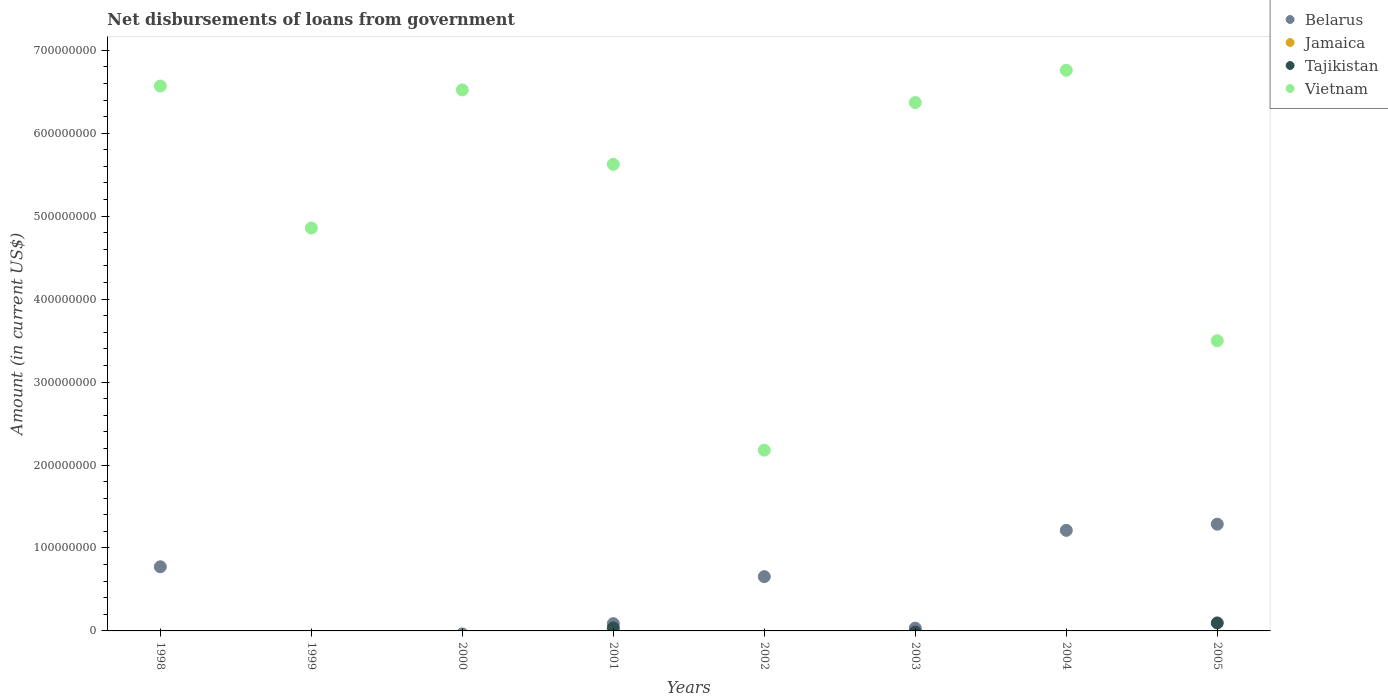What is the amount of loan disbursed from government in Jamaica in 1998?
Offer a very short reply. 0. Across all years, what is the maximum amount of loan disbursed from government in Vietnam?
Offer a terse response. 6.76e+08. In which year was the amount of loan disbursed from government in Belarus maximum?
Offer a very short reply. 2005. What is the total amount of loan disbursed from government in Vietnam in the graph?
Keep it short and to the point. 4.24e+09. What is the difference between the amount of loan disbursed from government in Belarus in 2002 and that in 2003?
Your answer should be very brief. 6.21e+07. What is the average amount of loan disbursed from government in Tajikistan per year?
Make the answer very short. 1.65e+06. In the year 2005, what is the difference between the amount of loan disbursed from government in Tajikistan and amount of loan disbursed from government in Belarus?
Make the answer very short. -1.19e+08. What is the ratio of the amount of loan disbursed from government in Belarus in 1998 to that in 2003?
Provide a short and direct response. 22.94. Is the amount of loan disbursed from government in Vietnam in 2000 less than that in 2005?
Give a very brief answer. No. What is the difference between the highest and the second highest amount of loan disbursed from government in Vietnam?
Give a very brief answer. 1.90e+07. What is the difference between the highest and the lowest amount of loan disbursed from government in Vietnam?
Your answer should be compact. 4.58e+08. In how many years, is the amount of loan disbursed from government in Jamaica greater than the average amount of loan disbursed from government in Jamaica taken over all years?
Provide a succinct answer. 0. Is the sum of the amount of loan disbursed from government in Vietnam in 2001 and 2002 greater than the maximum amount of loan disbursed from government in Belarus across all years?
Offer a terse response. Yes. Is it the case that in every year, the sum of the amount of loan disbursed from government in Tajikistan and amount of loan disbursed from government in Belarus  is greater than the sum of amount of loan disbursed from government in Vietnam and amount of loan disbursed from government in Jamaica?
Give a very brief answer. No. Is it the case that in every year, the sum of the amount of loan disbursed from government in Vietnam and amount of loan disbursed from government in Tajikistan  is greater than the amount of loan disbursed from government in Jamaica?
Your answer should be very brief. Yes. What is the difference between two consecutive major ticks on the Y-axis?
Give a very brief answer. 1.00e+08. Are the values on the major ticks of Y-axis written in scientific E-notation?
Provide a short and direct response. No. Does the graph contain any zero values?
Your response must be concise. Yes. What is the title of the graph?
Ensure brevity in your answer.  Net disbursements of loans from government. Does "Latin America(developing only)" appear as one of the legend labels in the graph?
Ensure brevity in your answer.  No. What is the label or title of the X-axis?
Provide a short and direct response. Years. What is the Amount (in current US$) in Belarus in 1998?
Offer a terse response. 7.73e+07. What is the Amount (in current US$) in Vietnam in 1998?
Give a very brief answer. 6.57e+08. What is the Amount (in current US$) in Belarus in 1999?
Give a very brief answer. 0. What is the Amount (in current US$) of Jamaica in 1999?
Make the answer very short. 0. What is the Amount (in current US$) of Tajikistan in 1999?
Provide a short and direct response. 0. What is the Amount (in current US$) of Vietnam in 1999?
Your response must be concise. 4.86e+08. What is the Amount (in current US$) of Jamaica in 2000?
Provide a succinct answer. 0. What is the Amount (in current US$) of Tajikistan in 2000?
Provide a succinct answer. 0. What is the Amount (in current US$) in Vietnam in 2000?
Give a very brief answer. 6.52e+08. What is the Amount (in current US$) of Belarus in 2001?
Your response must be concise. 8.79e+06. What is the Amount (in current US$) of Jamaica in 2001?
Provide a short and direct response. 0. What is the Amount (in current US$) in Tajikistan in 2001?
Provide a short and direct response. 3.58e+06. What is the Amount (in current US$) in Vietnam in 2001?
Keep it short and to the point. 5.62e+08. What is the Amount (in current US$) in Belarus in 2002?
Ensure brevity in your answer.  6.54e+07. What is the Amount (in current US$) of Jamaica in 2002?
Keep it short and to the point. 0. What is the Amount (in current US$) in Tajikistan in 2002?
Ensure brevity in your answer.  0. What is the Amount (in current US$) in Vietnam in 2002?
Offer a very short reply. 2.18e+08. What is the Amount (in current US$) of Belarus in 2003?
Your answer should be compact. 3.37e+06. What is the Amount (in current US$) of Jamaica in 2003?
Provide a succinct answer. 0. What is the Amount (in current US$) in Vietnam in 2003?
Your answer should be compact. 6.37e+08. What is the Amount (in current US$) of Belarus in 2004?
Provide a succinct answer. 1.21e+08. What is the Amount (in current US$) of Jamaica in 2004?
Ensure brevity in your answer.  0. What is the Amount (in current US$) of Vietnam in 2004?
Offer a terse response. 6.76e+08. What is the Amount (in current US$) in Belarus in 2005?
Give a very brief answer. 1.29e+08. What is the Amount (in current US$) of Tajikistan in 2005?
Your answer should be very brief. 9.63e+06. What is the Amount (in current US$) of Vietnam in 2005?
Give a very brief answer. 3.50e+08. Across all years, what is the maximum Amount (in current US$) in Belarus?
Keep it short and to the point. 1.29e+08. Across all years, what is the maximum Amount (in current US$) in Tajikistan?
Your answer should be compact. 9.63e+06. Across all years, what is the maximum Amount (in current US$) in Vietnam?
Your response must be concise. 6.76e+08. Across all years, what is the minimum Amount (in current US$) in Vietnam?
Your response must be concise. 2.18e+08. What is the total Amount (in current US$) of Belarus in the graph?
Your response must be concise. 4.05e+08. What is the total Amount (in current US$) of Tajikistan in the graph?
Offer a terse response. 1.32e+07. What is the total Amount (in current US$) in Vietnam in the graph?
Offer a very short reply. 4.24e+09. What is the difference between the Amount (in current US$) of Vietnam in 1998 and that in 1999?
Your answer should be compact. 1.71e+08. What is the difference between the Amount (in current US$) of Vietnam in 1998 and that in 2000?
Your response must be concise. 4.68e+06. What is the difference between the Amount (in current US$) of Belarus in 1998 and that in 2001?
Provide a succinct answer. 6.85e+07. What is the difference between the Amount (in current US$) in Vietnam in 1998 and that in 2001?
Your response must be concise. 9.44e+07. What is the difference between the Amount (in current US$) in Belarus in 1998 and that in 2002?
Your answer should be compact. 1.19e+07. What is the difference between the Amount (in current US$) of Vietnam in 1998 and that in 2002?
Offer a very short reply. 4.39e+08. What is the difference between the Amount (in current US$) of Belarus in 1998 and that in 2003?
Keep it short and to the point. 7.40e+07. What is the difference between the Amount (in current US$) of Vietnam in 1998 and that in 2003?
Your answer should be very brief. 2.00e+07. What is the difference between the Amount (in current US$) in Belarus in 1998 and that in 2004?
Your answer should be very brief. -4.39e+07. What is the difference between the Amount (in current US$) in Vietnam in 1998 and that in 2004?
Provide a short and direct response. -1.90e+07. What is the difference between the Amount (in current US$) of Belarus in 1998 and that in 2005?
Offer a terse response. -5.14e+07. What is the difference between the Amount (in current US$) in Vietnam in 1998 and that in 2005?
Your answer should be very brief. 3.07e+08. What is the difference between the Amount (in current US$) in Vietnam in 1999 and that in 2000?
Ensure brevity in your answer.  -1.66e+08. What is the difference between the Amount (in current US$) of Vietnam in 1999 and that in 2001?
Make the answer very short. -7.67e+07. What is the difference between the Amount (in current US$) in Vietnam in 1999 and that in 2002?
Offer a terse response. 2.68e+08. What is the difference between the Amount (in current US$) of Vietnam in 1999 and that in 2003?
Offer a terse response. -1.51e+08. What is the difference between the Amount (in current US$) of Vietnam in 1999 and that in 2004?
Ensure brevity in your answer.  -1.90e+08. What is the difference between the Amount (in current US$) of Vietnam in 1999 and that in 2005?
Offer a terse response. 1.36e+08. What is the difference between the Amount (in current US$) of Vietnam in 2000 and that in 2001?
Ensure brevity in your answer.  8.97e+07. What is the difference between the Amount (in current US$) in Vietnam in 2000 and that in 2002?
Provide a succinct answer. 4.34e+08. What is the difference between the Amount (in current US$) of Vietnam in 2000 and that in 2003?
Your answer should be very brief. 1.53e+07. What is the difference between the Amount (in current US$) of Vietnam in 2000 and that in 2004?
Ensure brevity in your answer.  -2.37e+07. What is the difference between the Amount (in current US$) of Vietnam in 2000 and that in 2005?
Ensure brevity in your answer.  3.02e+08. What is the difference between the Amount (in current US$) of Belarus in 2001 and that in 2002?
Your answer should be very brief. -5.66e+07. What is the difference between the Amount (in current US$) in Vietnam in 2001 and that in 2002?
Give a very brief answer. 3.45e+08. What is the difference between the Amount (in current US$) in Belarus in 2001 and that in 2003?
Give a very brief answer. 5.42e+06. What is the difference between the Amount (in current US$) in Vietnam in 2001 and that in 2003?
Make the answer very short. -7.45e+07. What is the difference between the Amount (in current US$) in Belarus in 2001 and that in 2004?
Offer a terse response. -1.12e+08. What is the difference between the Amount (in current US$) of Vietnam in 2001 and that in 2004?
Your response must be concise. -1.13e+08. What is the difference between the Amount (in current US$) of Belarus in 2001 and that in 2005?
Offer a very short reply. -1.20e+08. What is the difference between the Amount (in current US$) of Tajikistan in 2001 and that in 2005?
Keep it short and to the point. -6.04e+06. What is the difference between the Amount (in current US$) of Vietnam in 2001 and that in 2005?
Keep it short and to the point. 2.13e+08. What is the difference between the Amount (in current US$) in Belarus in 2002 and that in 2003?
Your answer should be compact. 6.21e+07. What is the difference between the Amount (in current US$) in Vietnam in 2002 and that in 2003?
Give a very brief answer. -4.19e+08. What is the difference between the Amount (in current US$) in Belarus in 2002 and that in 2004?
Keep it short and to the point. -5.58e+07. What is the difference between the Amount (in current US$) of Vietnam in 2002 and that in 2004?
Your response must be concise. -4.58e+08. What is the difference between the Amount (in current US$) of Belarus in 2002 and that in 2005?
Offer a terse response. -6.33e+07. What is the difference between the Amount (in current US$) in Vietnam in 2002 and that in 2005?
Your response must be concise. -1.32e+08. What is the difference between the Amount (in current US$) of Belarus in 2003 and that in 2004?
Make the answer very short. -1.18e+08. What is the difference between the Amount (in current US$) of Vietnam in 2003 and that in 2004?
Ensure brevity in your answer.  -3.90e+07. What is the difference between the Amount (in current US$) in Belarus in 2003 and that in 2005?
Provide a short and direct response. -1.25e+08. What is the difference between the Amount (in current US$) in Vietnam in 2003 and that in 2005?
Your answer should be very brief. 2.87e+08. What is the difference between the Amount (in current US$) in Belarus in 2004 and that in 2005?
Your answer should be compact. -7.44e+06. What is the difference between the Amount (in current US$) in Vietnam in 2004 and that in 2005?
Keep it short and to the point. 3.26e+08. What is the difference between the Amount (in current US$) of Belarus in 1998 and the Amount (in current US$) of Vietnam in 1999?
Offer a very short reply. -4.08e+08. What is the difference between the Amount (in current US$) in Belarus in 1998 and the Amount (in current US$) in Vietnam in 2000?
Your answer should be compact. -5.75e+08. What is the difference between the Amount (in current US$) of Belarus in 1998 and the Amount (in current US$) of Tajikistan in 2001?
Ensure brevity in your answer.  7.37e+07. What is the difference between the Amount (in current US$) in Belarus in 1998 and the Amount (in current US$) in Vietnam in 2001?
Your response must be concise. -4.85e+08. What is the difference between the Amount (in current US$) of Belarus in 1998 and the Amount (in current US$) of Vietnam in 2002?
Ensure brevity in your answer.  -1.41e+08. What is the difference between the Amount (in current US$) in Belarus in 1998 and the Amount (in current US$) in Vietnam in 2003?
Offer a terse response. -5.60e+08. What is the difference between the Amount (in current US$) of Belarus in 1998 and the Amount (in current US$) of Vietnam in 2004?
Offer a very short reply. -5.99e+08. What is the difference between the Amount (in current US$) of Belarus in 1998 and the Amount (in current US$) of Tajikistan in 2005?
Ensure brevity in your answer.  6.77e+07. What is the difference between the Amount (in current US$) of Belarus in 1998 and the Amount (in current US$) of Vietnam in 2005?
Your response must be concise. -2.72e+08. What is the difference between the Amount (in current US$) of Belarus in 2001 and the Amount (in current US$) of Vietnam in 2002?
Ensure brevity in your answer.  -2.09e+08. What is the difference between the Amount (in current US$) of Tajikistan in 2001 and the Amount (in current US$) of Vietnam in 2002?
Offer a terse response. -2.14e+08. What is the difference between the Amount (in current US$) in Belarus in 2001 and the Amount (in current US$) in Vietnam in 2003?
Offer a terse response. -6.28e+08. What is the difference between the Amount (in current US$) of Tajikistan in 2001 and the Amount (in current US$) of Vietnam in 2003?
Offer a terse response. -6.33e+08. What is the difference between the Amount (in current US$) of Belarus in 2001 and the Amount (in current US$) of Vietnam in 2004?
Ensure brevity in your answer.  -6.67e+08. What is the difference between the Amount (in current US$) of Tajikistan in 2001 and the Amount (in current US$) of Vietnam in 2004?
Your answer should be very brief. -6.72e+08. What is the difference between the Amount (in current US$) of Belarus in 2001 and the Amount (in current US$) of Tajikistan in 2005?
Ensure brevity in your answer.  -8.33e+05. What is the difference between the Amount (in current US$) of Belarus in 2001 and the Amount (in current US$) of Vietnam in 2005?
Ensure brevity in your answer.  -3.41e+08. What is the difference between the Amount (in current US$) of Tajikistan in 2001 and the Amount (in current US$) of Vietnam in 2005?
Offer a very short reply. -3.46e+08. What is the difference between the Amount (in current US$) in Belarus in 2002 and the Amount (in current US$) in Vietnam in 2003?
Make the answer very short. -5.72e+08. What is the difference between the Amount (in current US$) of Belarus in 2002 and the Amount (in current US$) of Vietnam in 2004?
Make the answer very short. -6.10e+08. What is the difference between the Amount (in current US$) of Belarus in 2002 and the Amount (in current US$) of Tajikistan in 2005?
Provide a short and direct response. 5.58e+07. What is the difference between the Amount (in current US$) in Belarus in 2002 and the Amount (in current US$) in Vietnam in 2005?
Ensure brevity in your answer.  -2.84e+08. What is the difference between the Amount (in current US$) of Belarus in 2003 and the Amount (in current US$) of Vietnam in 2004?
Ensure brevity in your answer.  -6.73e+08. What is the difference between the Amount (in current US$) of Belarus in 2003 and the Amount (in current US$) of Tajikistan in 2005?
Give a very brief answer. -6.26e+06. What is the difference between the Amount (in current US$) of Belarus in 2003 and the Amount (in current US$) of Vietnam in 2005?
Offer a very short reply. -3.46e+08. What is the difference between the Amount (in current US$) in Belarus in 2004 and the Amount (in current US$) in Tajikistan in 2005?
Offer a terse response. 1.12e+08. What is the difference between the Amount (in current US$) in Belarus in 2004 and the Amount (in current US$) in Vietnam in 2005?
Provide a short and direct response. -2.29e+08. What is the average Amount (in current US$) of Belarus per year?
Keep it short and to the point. 5.06e+07. What is the average Amount (in current US$) of Jamaica per year?
Your answer should be very brief. 0. What is the average Amount (in current US$) of Tajikistan per year?
Offer a terse response. 1.65e+06. What is the average Amount (in current US$) of Vietnam per year?
Provide a succinct answer. 5.30e+08. In the year 1998, what is the difference between the Amount (in current US$) of Belarus and Amount (in current US$) of Vietnam?
Ensure brevity in your answer.  -5.80e+08. In the year 2001, what is the difference between the Amount (in current US$) of Belarus and Amount (in current US$) of Tajikistan?
Provide a succinct answer. 5.21e+06. In the year 2001, what is the difference between the Amount (in current US$) of Belarus and Amount (in current US$) of Vietnam?
Ensure brevity in your answer.  -5.54e+08. In the year 2001, what is the difference between the Amount (in current US$) in Tajikistan and Amount (in current US$) in Vietnam?
Ensure brevity in your answer.  -5.59e+08. In the year 2002, what is the difference between the Amount (in current US$) of Belarus and Amount (in current US$) of Vietnam?
Ensure brevity in your answer.  -1.52e+08. In the year 2003, what is the difference between the Amount (in current US$) of Belarus and Amount (in current US$) of Vietnam?
Provide a succinct answer. -6.34e+08. In the year 2004, what is the difference between the Amount (in current US$) of Belarus and Amount (in current US$) of Vietnam?
Make the answer very short. -5.55e+08. In the year 2005, what is the difference between the Amount (in current US$) in Belarus and Amount (in current US$) in Tajikistan?
Make the answer very short. 1.19e+08. In the year 2005, what is the difference between the Amount (in current US$) of Belarus and Amount (in current US$) of Vietnam?
Make the answer very short. -2.21e+08. In the year 2005, what is the difference between the Amount (in current US$) of Tajikistan and Amount (in current US$) of Vietnam?
Your answer should be compact. -3.40e+08. What is the ratio of the Amount (in current US$) of Vietnam in 1998 to that in 1999?
Provide a short and direct response. 1.35. What is the ratio of the Amount (in current US$) in Belarus in 1998 to that in 2001?
Offer a very short reply. 8.79. What is the ratio of the Amount (in current US$) in Vietnam in 1998 to that in 2001?
Your response must be concise. 1.17. What is the ratio of the Amount (in current US$) of Belarus in 1998 to that in 2002?
Keep it short and to the point. 1.18. What is the ratio of the Amount (in current US$) of Vietnam in 1998 to that in 2002?
Ensure brevity in your answer.  3.01. What is the ratio of the Amount (in current US$) of Belarus in 1998 to that in 2003?
Your response must be concise. 22.94. What is the ratio of the Amount (in current US$) in Vietnam in 1998 to that in 2003?
Offer a very short reply. 1.03. What is the ratio of the Amount (in current US$) of Belarus in 1998 to that in 2004?
Offer a terse response. 0.64. What is the ratio of the Amount (in current US$) in Vietnam in 1998 to that in 2004?
Your answer should be compact. 0.97. What is the ratio of the Amount (in current US$) of Belarus in 1998 to that in 2005?
Make the answer very short. 0.6. What is the ratio of the Amount (in current US$) in Vietnam in 1998 to that in 2005?
Provide a succinct answer. 1.88. What is the ratio of the Amount (in current US$) of Vietnam in 1999 to that in 2000?
Your response must be concise. 0.74. What is the ratio of the Amount (in current US$) in Vietnam in 1999 to that in 2001?
Give a very brief answer. 0.86. What is the ratio of the Amount (in current US$) in Vietnam in 1999 to that in 2002?
Your response must be concise. 2.23. What is the ratio of the Amount (in current US$) of Vietnam in 1999 to that in 2003?
Ensure brevity in your answer.  0.76. What is the ratio of the Amount (in current US$) of Vietnam in 1999 to that in 2004?
Offer a terse response. 0.72. What is the ratio of the Amount (in current US$) in Vietnam in 1999 to that in 2005?
Your answer should be very brief. 1.39. What is the ratio of the Amount (in current US$) in Vietnam in 2000 to that in 2001?
Your answer should be compact. 1.16. What is the ratio of the Amount (in current US$) in Vietnam in 2000 to that in 2002?
Keep it short and to the point. 2.99. What is the ratio of the Amount (in current US$) in Vietnam in 2000 to that in 2003?
Give a very brief answer. 1.02. What is the ratio of the Amount (in current US$) of Vietnam in 2000 to that in 2004?
Give a very brief answer. 0.96. What is the ratio of the Amount (in current US$) of Vietnam in 2000 to that in 2005?
Give a very brief answer. 1.86. What is the ratio of the Amount (in current US$) in Belarus in 2001 to that in 2002?
Offer a terse response. 0.13. What is the ratio of the Amount (in current US$) in Vietnam in 2001 to that in 2002?
Offer a terse response. 2.58. What is the ratio of the Amount (in current US$) in Belarus in 2001 to that in 2003?
Ensure brevity in your answer.  2.61. What is the ratio of the Amount (in current US$) of Vietnam in 2001 to that in 2003?
Your answer should be compact. 0.88. What is the ratio of the Amount (in current US$) of Belarus in 2001 to that in 2004?
Provide a succinct answer. 0.07. What is the ratio of the Amount (in current US$) of Vietnam in 2001 to that in 2004?
Provide a succinct answer. 0.83. What is the ratio of the Amount (in current US$) of Belarus in 2001 to that in 2005?
Your response must be concise. 0.07. What is the ratio of the Amount (in current US$) in Tajikistan in 2001 to that in 2005?
Provide a short and direct response. 0.37. What is the ratio of the Amount (in current US$) of Vietnam in 2001 to that in 2005?
Provide a succinct answer. 1.61. What is the ratio of the Amount (in current US$) in Belarus in 2002 to that in 2003?
Your answer should be very brief. 19.41. What is the ratio of the Amount (in current US$) of Vietnam in 2002 to that in 2003?
Your response must be concise. 0.34. What is the ratio of the Amount (in current US$) in Belarus in 2002 to that in 2004?
Provide a short and direct response. 0.54. What is the ratio of the Amount (in current US$) in Vietnam in 2002 to that in 2004?
Make the answer very short. 0.32. What is the ratio of the Amount (in current US$) of Belarus in 2002 to that in 2005?
Keep it short and to the point. 0.51. What is the ratio of the Amount (in current US$) in Vietnam in 2002 to that in 2005?
Your response must be concise. 0.62. What is the ratio of the Amount (in current US$) of Belarus in 2003 to that in 2004?
Your answer should be very brief. 0.03. What is the ratio of the Amount (in current US$) of Vietnam in 2003 to that in 2004?
Your answer should be compact. 0.94. What is the ratio of the Amount (in current US$) of Belarus in 2003 to that in 2005?
Your answer should be very brief. 0.03. What is the ratio of the Amount (in current US$) of Vietnam in 2003 to that in 2005?
Offer a very short reply. 1.82. What is the ratio of the Amount (in current US$) in Belarus in 2004 to that in 2005?
Offer a very short reply. 0.94. What is the ratio of the Amount (in current US$) in Vietnam in 2004 to that in 2005?
Ensure brevity in your answer.  1.93. What is the difference between the highest and the second highest Amount (in current US$) in Belarus?
Keep it short and to the point. 7.44e+06. What is the difference between the highest and the second highest Amount (in current US$) in Vietnam?
Ensure brevity in your answer.  1.90e+07. What is the difference between the highest and the lowest Amount (in current US$) of Belarus?
Your answer should be compact. 1.29e+08. What is the difference between the highest and the lowest Amount (in current US$) in Tajikistan?
Provide a succinct answer. 9.63e+06. What is the difference between the highest and the lowest Amount (in current US$) of Vietnam?
Your answer should be very brief. 4.58e+08. 